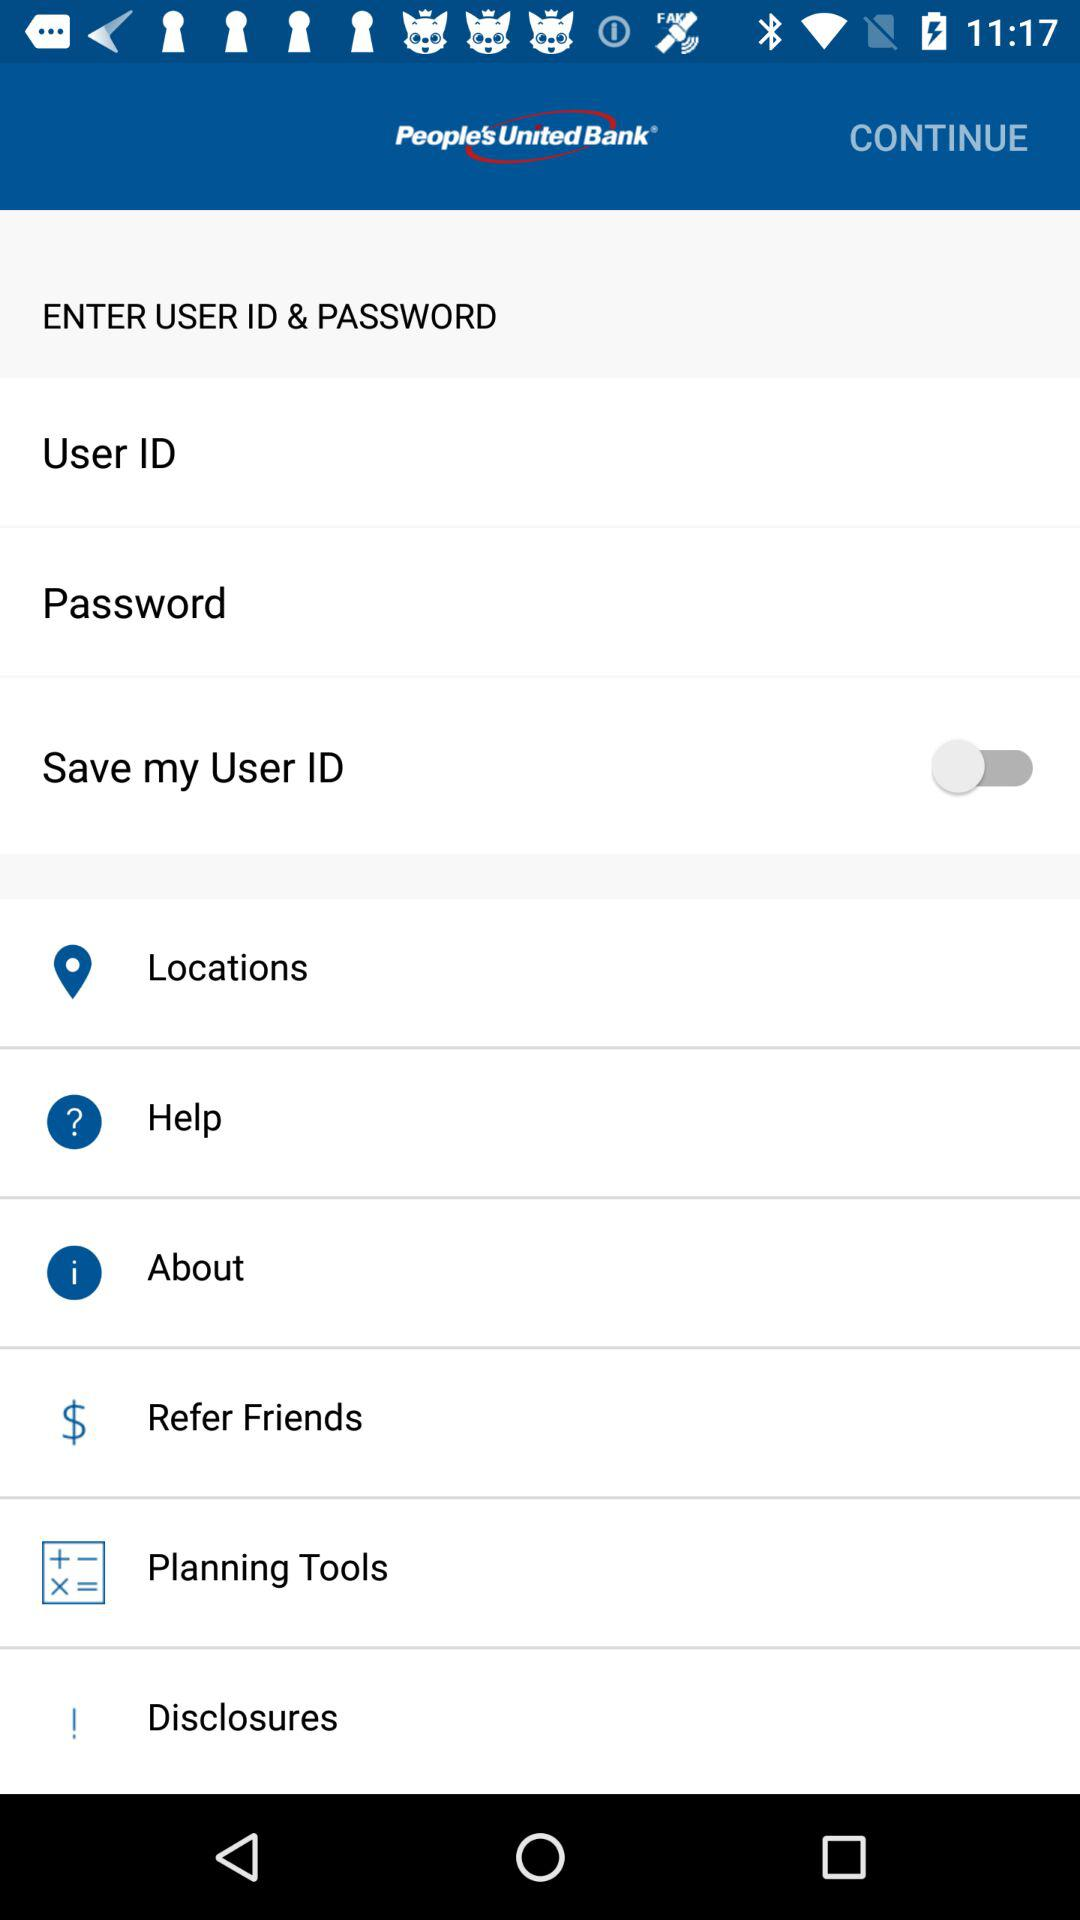What is the bank name? The bank name is "People's United Bank". 